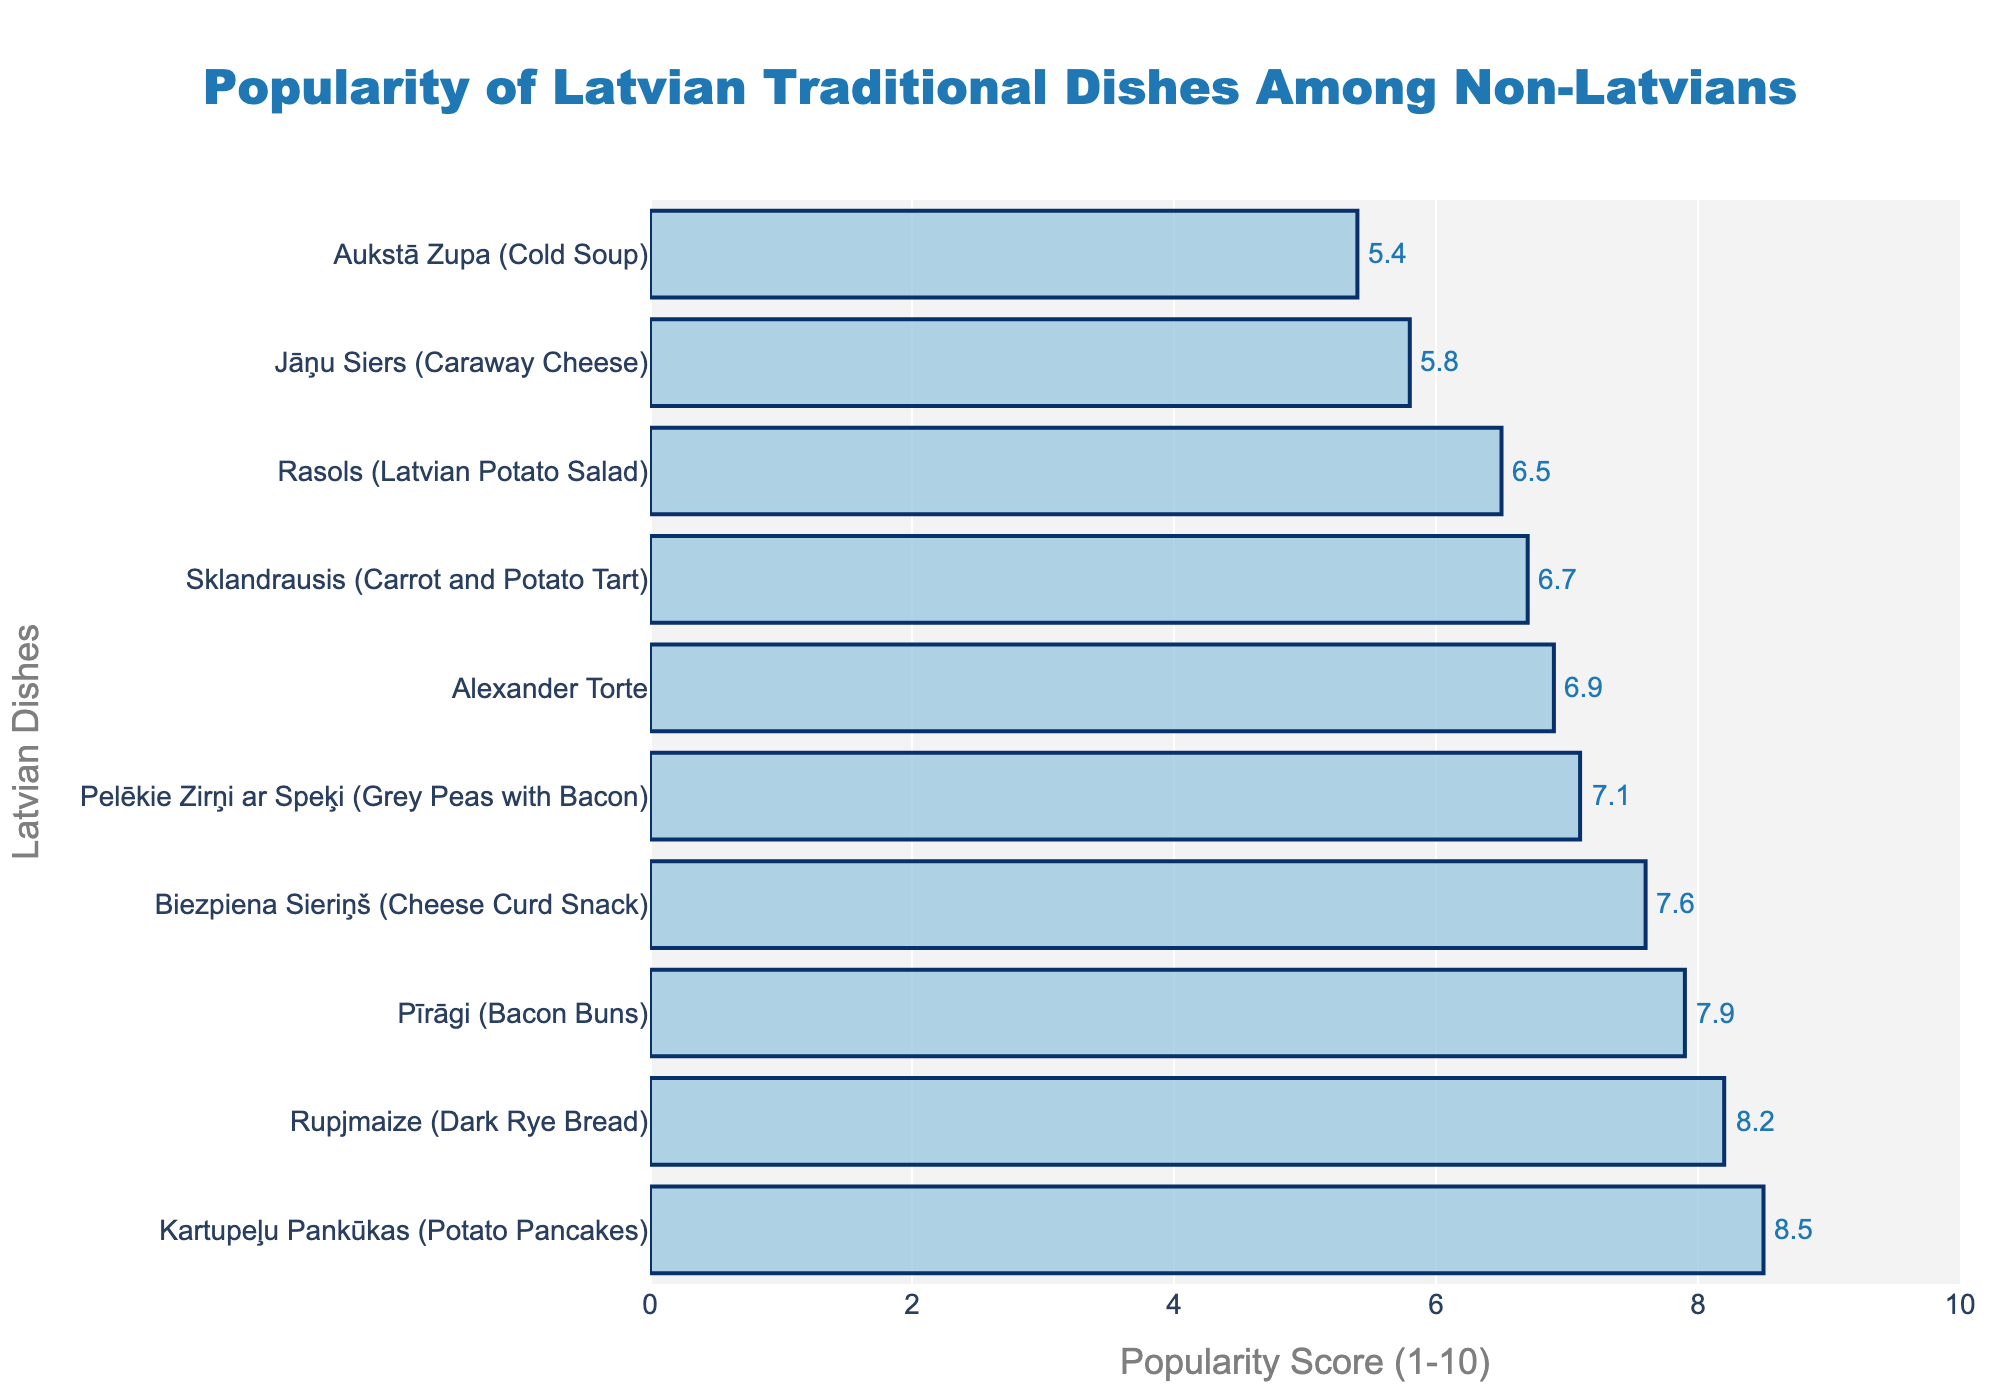Which dish has the highest popularity score? Scan the bars to find the longest one and identify its corresponding dish. The longest bar corresponds to Kartupeļu Pankūkas (Potato Pancakes).
Answer: Kartupeļu Pankūkas (Potato Pancakes) Which dish has the lowest popularity score? Scan the bars to find the shortest one and identify its corresponding dish. The shortest bar corresponds to Aukstā Zupa (Cold Soup).
Answer: Aukstā Zupa (Cold Soup) What is the combined popularity score of Sklandrausis (Carrot and Potato Tart) and Alexander Torte? Look at the popularity scores of Sklandrausis (6.7) and Alexander Torte (6.9). Sum them up: 6.7 + 6.9 = 13.6.
Answer: 13.6 Which dish is more popular, Rupjmaize (Dark Rye Bread) or Pīrāgi (Bacon Buns)? Compare the popularity scores of Rupjmaize (8.2) and Pīrāgi (7.9). Since 8.2 > 7.9, Rupjmaize is more popular.
Answer: Rupjmaize (Dark Rye Bread) How much more popular are Kartupeļu Pankūkas (Potato Pancakes) compared to Aukstā Zupa (Cold Soup)? Subtract the popularity score of Aukstā Zupa (5.4) from Kartupeļu Pankūkas (8.5): 8.5 - 5.4 = 3.1.
Answer: 3.1 What is the average popularity score of the top three dishes? Identify the top three dishes based on their scores: Kartupeļu Pankūkas (8.5), Rupjmaize (8.2), and Pīrāgi (7.9). Calculate their average: (8.5 + 8.2 + 7.9) / 3 = 24.6 / 3 = 8.2.
Answer: 8.2 Which has a higher score, Biezpiena Sieriņš (Cheese Curd Snack) or Rasols (Latvian Potato Salad)? Compare the popularity scores of Biezpiena Sieriņš (7.6) and Rasols (6.5). Since 7.6 > 6.5, Biezpiena Sieriņš has a higher score.
Answer: Biezpiena Sieriņš (Cheese Curd Snack) Are any dishes tied in their popularity scores? Examine the popularity scores of all listed dishes. No dishes have the same score.
Answer: No What is the total popularity score for all the dishes combined? Sum the popularity scores of all dishes: 8.2 + 6.7 + 7.9 + 6.5 + 5.8 + 7.1 + 6.9 + 7.6 + 5.4 + 8.5 = 70.6
Answer: 70.6 How many dishes have a popularity score above 7? Count the number of dishes with scores above 7: Rupjmaize (8.2), Pīrāgi (7.9), Pelēkie Zirņi ar Speķi (7.1), Biezpiena Sieriņš (7.6), and Kartupeļu Pankūkas (8.5). There are five such dishes.
Answer: 5 